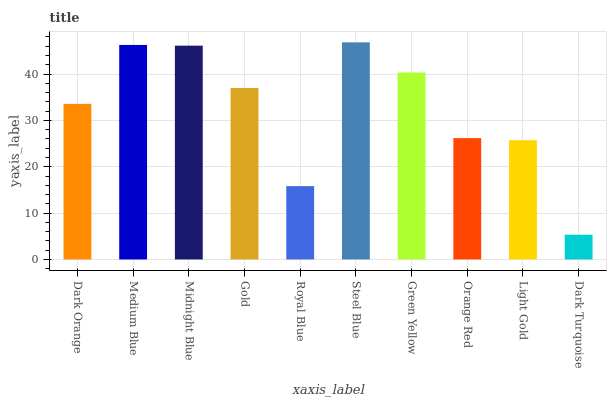Is Dark Turquoise the minimum?
Answer yes or no. Yes. Is Steel Blue the maximum?
Answer yes or no. Yes. Is Medium Blue the minimum?
Answer yes or no. No. Is Medium Blue the maximum?
Answer yes or no. No. Is Medium Blue greater than Dark Orange?
Answer yes or no. Yes. Is Dark Orange less than Medium Blue?
Answer yes or no. Yes. Is Dark Orange greater than Medium Blue?
Answer yes or no. No. Is Medium Blue less than Dark Orange?
Answer yes or no. No. Is Gold the high median?
Answer yes or no. Yes. Is Dark Orange the low median?
Answer yes or no. Yes. Is Green Yellow the high median?
Answer yes or no. No. Is Light Gold the low median?
Answer yes or no. No. 